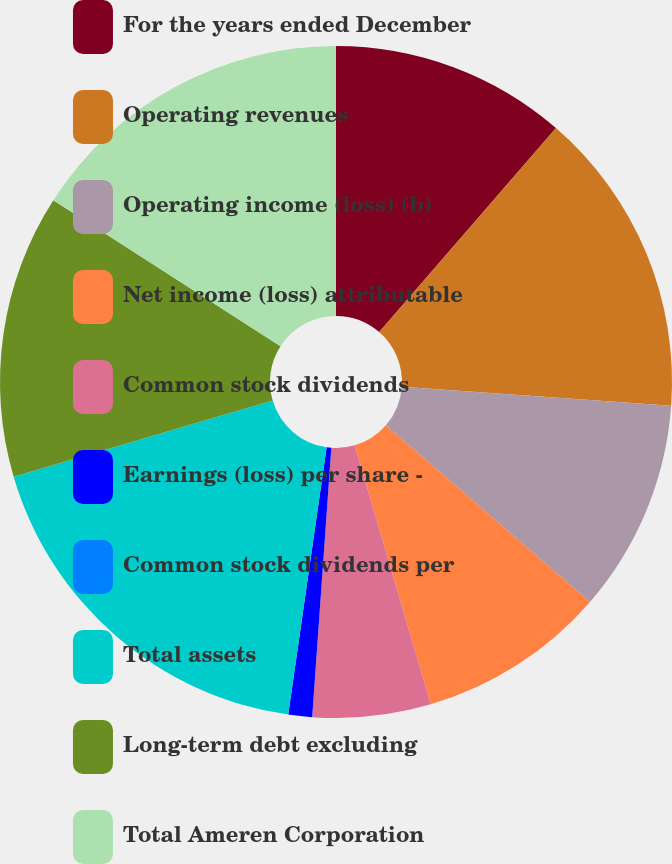Convert chart. <chart><loc_0><loc_0><loc_500><loc_500><pie_chart><fcel>For the years ended December<fcel>Operating revenues<fcel>Operating income (loss) (b)<fcel>Net income (loss) attributable<fcel>Common stock dividends<fcel>Earnings (loss) per share -<fcel>Common stock dividends per<fcel>Total assets<fcel>Long-term debt excluding<fcel>Total Ameren Corporation<nl><fcel>11.36%<fcel>14.77%<fcel>10.23%<fcel>9.09%<fcel>5.68%<fcel>1.14%<fcel>0.0%<fcel>18.18%<fcel>13.64%<fcel>15.91%<nl></chart> 